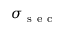Convert formula to latex. <formula><loc_0><loc_0><loc_500><loc_500>\sigma _ { s e c }</formula> 